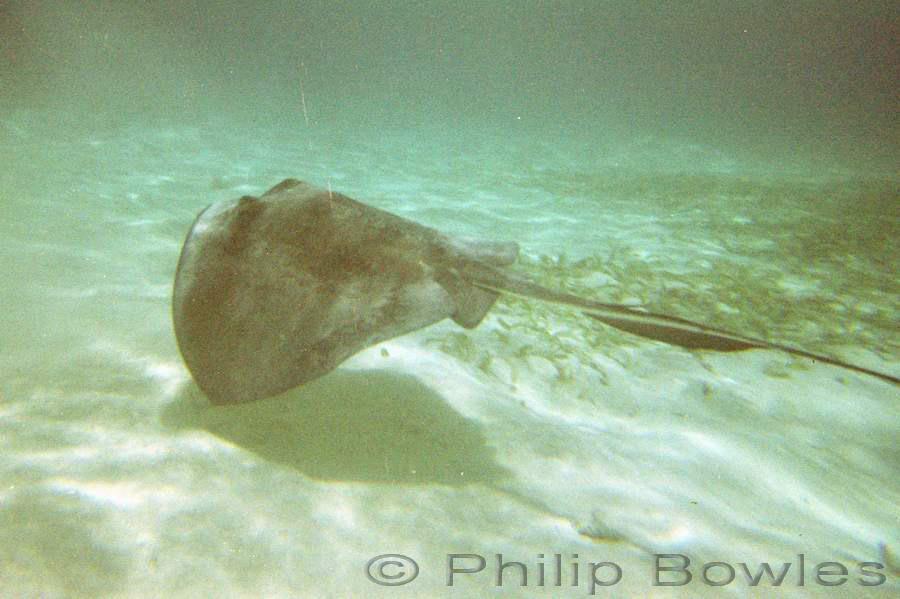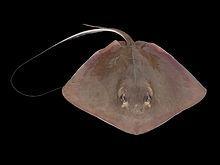The first image is the image on the left, the second image is the image on the right. For the images shown, is this caption "In one image, a dark, flat, purple-blue fish has a white underside and a long thin tail." true? Answer yes or no. No. 